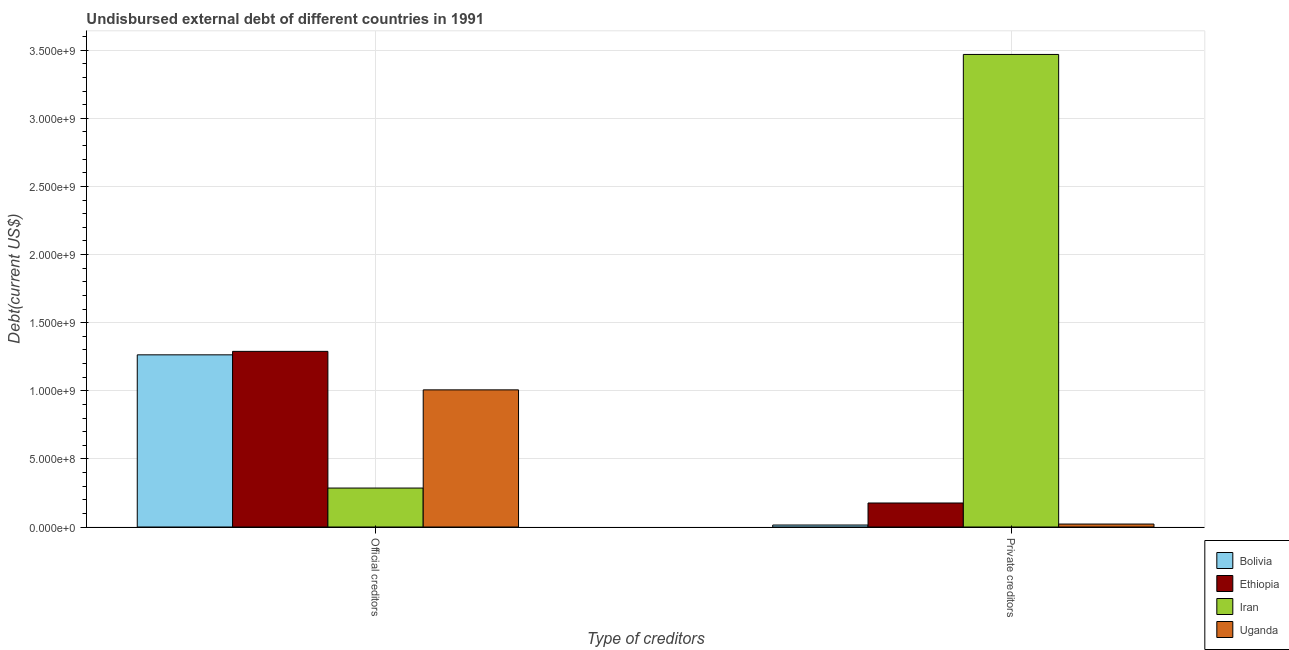Are the number of bars on each tick of the X-axis equal?
Provide a succinct answer. Yes. How many bars are there on the 1st tick from the right?
Ensure brevity in your answer.  4. What is the label of the 1st group of bars from the left?
Keep it short and to the point. Official creditors. What is the undisbursed external debt of official creditors in Ethiopia?
Provide a succinct answer. 1.29e+09. Across all countries, what is the maximum undisbursed external debt of official creditors?
Your answer should be very brief. 1.29e+09. Across all countries, what is the minimum undisbursed external debt of official creditors?
Your response must be concise. 2.86e+08. In which country was the undisbursed external debt of private creditors maximum?
Ensure brevity in your answer.  Iran. In which country was the undisbursed external debt of official creditors minimum?
Offer a terse response. Iran. What is the total undisbursed external debt of official creditors in the graph?
Offer a very short reply. 3.85e+09. What is the difference between the undisbursed external debt of private creditors in Bolivia and that in Ethiopia?
Your response must be concise. -1.62e+08. What is the difference between the undisbursed external debt of official creditors in Uganda and the undisbursed external debt of private creditors in Ethiopia?
Provide a short and direct response. 8.30e+08. What is the average undisbursed external debt of official creditors per country?
Offer a terse response. 9.61e+08. What is the difference between the undisbursed external debt of private creditors and undisbursed external debt of official creditors in Uganda?
Your answer should be compact. -9.85e+08. What is the ratio of the undisbursed external debt of private creditors in Bolivia to that in Iran?
Give a very brief answer. 0. What does the 4th bar from the left in Private creditors represents?
Provide a short and direct response. Uganda. What does the 1st bar from the right in Private creditors represents?
Your answer should be very brief. Uganda. Are the values on the major ticks of Y-axis written in scientific E-notation?
Your response must be concise. Yes. Where does the legend appear in the graph?
Provide a succinct answer. Bottom right. How are the legend labels stacked?
Make the answer very short. Vertical. What is the title of the graph?
Your answer should be very brief. Undisbursed external debt of different countries in 1991. Does "Equatorial Guinea" appear as one of the legend labels in the graph?
Offer a very short reply. No. What is the label or title of the X-axis?
Ensure brevity in your answer.  Type of creditors. What is the label or title of the Y-axis?
Give a very brief answer. Debt(current US$). What is the Debt(current US$) in Bolivia in Official creditors?
Offer a terse response. 1.26e+09. What is the Debt(current US$) in Ethiopia in Official creditors?
Provide a short and direct response. 1.29e+09. What is the Debt(current US$) in Iran in Official creditors?
Offer a very short reply. 2.86e+08. What is the Debt(current US$) in Uganda in Official creditors?
Ensure brevity in your answer.  1.01e+09. What is the Debt(current US$) in Bolivia in Private creditors?
Give a very brief answer. 1.46e+07. What is the Debt(current US$) of Ethiopia in Private creditors?
Provide a succinct answer. 1.76e+08. What is the Debt(current US$) in Iran in Private creditors?
Your answer should be very brief. 3.47e+09. What is the Debt(current US$) in Uganda in Private creditors?
Offer a very short reply. 2.17e+07. Across all Type of creditors, what is the maximum Debt(current US$) in Bolivia?
Your answer should be compact. 1.26e+09. Across all Type of creditors, what is the maximum Debt(current US$) of Ethiopia?
Make the answer very short. 1.29e+09. Across all Type of creditors, what is the maximum Debt(current US$) in Iran?
Ensure brevity in your answer.  3.47e+09. Across all Type of creditors, what is the maximum Debt(current US$) of Uganda?
Provide a succinct answer. 1.01e+09. Across all Type of creditors, what is the minimum Debt(current US$) in Bolivia?
Offer a terse response. 1.46e+07. Across all Type of creditors, what is the minimum Debt(current US$) in Ethiopia?
Offer a terse response. 1.76e+08. Across all Type of creditors, what is the minimum Debt(current US$) in Iran?
Ensure brevity in your answer.  2.86e+08. Across all Type of creditors, what is the minimum Debt(current US$) in Uganda?
Make the answer very short. 2.17e+07. What is the total Debt(current US$) of Bolivia in the graph?
Make the answer very short. 1.28e+09. What is the total Debt(current US$) of Ethiopia in the graph?
Keep it short and to the point. 1.47e+09. What is the total Debt(current US$) in Iran in the graph?
Offer a terse response. 3.75e+09. What is the total Debt(current US$) of Uganda in the graph?
Offer a very short reply. 1.03e+09. What is the difference between the Debt(current US$) in Bolivia in Official creditors and that in Private creditors?
Your answer should be very brief. 1.25e+09. What is the difference between the Debt(current US$) of Ethiopia in Official creditors and that in Private creditors?
Make the answer very short. 1.11e+09. What is the difference between the Debt(current US$) of Iran in Official creditors and that in Private creditors?
Provide a short and direct response. -3.18e+09. What is the difference between the Debt(current US$) in Uganda in Official creditors and that in Private creditors?
Make the answer very short. 9.85e+08. What is the difference between the Debt(current US$) in Bolivia in Official creditors and the Debt(current US$) in Ethiopia in Private creditors?
Offer a very short reply. 1.09e+09. What is the difference between the Debt(current US$) in Bolivia in Official creditors and the Debt(current US$) in Iran in Private creditors?
Your answer should be compact. -2.20e+09. What is the difference between the Debt(current US$) of Bolivia in Official creditors and the Debt(current US$) of Uganda in Private creditors?
Keep it short and to the point. 1.24e+09. What is the difference between the Debt(current US$) in Ethiopia in Official creditors and the Debt(current US$) in Iran in Private creditors?
Provide a short and direct response. -2.18e+09. What is the difference between the Debt(current US$) of Ethiopia in Official creditors and the Debt(current US$) of Uganda in Private creditors?
Give a very brief answer. 1.27e+09. What is the difference between the Debt(current US$) in Iran in Official creditors and the Debt(current US$) in Uganda in Private creditors?
Keep it short and to the point. 2.64e+08. What is the average Debt(current US$) in Bolivia per Type of creditors?
Your answer should be compact. 6.39e+08. What is the average Debt(current US$) in Ethiopia per Type of creditors?
Offer a very short reply. 7.33e+08. What is the average Debt(current US$) in Iran per Type of creditors?
Offer a very short reply. 1.88e+09. What is the average Debt(current US$) in Uganda per Type of creditors?
Your answer should be very brief. 5.14e+08. What is the difference between the Debt(current US$) of Bolivia and Debt(current US$) of Ethiopia in Official creditors?
Your answer should be compact. -2.55e+07. What is the difference between the Debt(current US$) in Bolivia and Debt(current US$) in Iran in Official creditors?
Your answer should be very brief. 9.78e+08. What is the difference between the Debt(current US$) of Bolivia and Debt(current US$) of Uganda in Official creditors?
Provide a succinct answer. 2.57e+08. What is the difference between the Debt(current US$) in Ethiopia and Debt(current US$) in Iran in Official creditors?
Make the answer very short. 1.00e+09. What is the difference between the Debt(current US$) of Ethiopia and Debt(current US$) of Uganda in Official creditors?
Your answer should be very brief. 2.83e+08. What is the difference between the Debt(current US$) of Iran and Debt(current US$) of Uganda in Official creditors?
Offer a very short reply. -7.21e+08. What is the difference between the Debt(current US$) of Bolivia and Debt(current US$) of Ethiopia in Private creditors?
Offer a terse response. -1.62e+08. What is the difference between the Debt(current US$) in Bolivia and Debt(current US$) in Iran in Private creditors?
Give a very brief answer. -3.45e+09. What is the difference between the Debt(current US$) in Bolivia and Debt(current US$) in Uganda in Private creditors?
Keep it short and to the point. -7.11e+06. What is the difference between the Debt(current US$) in Ethiopia and Debt(current US$) in Iran in Private creditors?
Make the answer very short. -3.29e+09. What is the difference between the Debt(current US$) of Ethiopia and Debt(current US$) of Uganda in Private creditors?
Give a very brief answer. 1.55e+08. What is the difference between the Debt(current US$) in Iran and Debt(current US$) in Uganda in Private creditors?
Offer a very short reply. 3.45e+09. What is the ratio of the Debt(current US$) in Bolivia in Official creditors to that in Private creditors?
Make the answer very short. 86.36. What is the ratio of the Debt(current US$) in Ethiopia in Official creditors to that in Private creditors?
Your answer should be compact. 7.31. What is the ratio of the Debt(current US$) of Iran in Official creditors to that in Private creditors?
Make the answer very short. 0.08. What is the ratio of the Debt(current US$) in Uganda in Official creditors to that in Private creditors?
Your answer should be compact. 46.3. What is the difference between the highest and the second highest Debt(current US$) in Bolivia?
Your answer should be compact. 1.25e+09. What is the difference between the highest and the second highest Debt(current US$) in Ethiopia?
Your response must be concise. 1.11e+09. What is the difference between the highest and the second highest Debt(current US$) of Iran?
Ensure brevity in your answer.  3.18e+09. What is the difference between the highest and the second highest Debt(current US$) in Uganda?
Ensure brevity in your answer.  9.85e+08. What is the difference between the highest and the lowest Debt(current US$) of Bolivia?
Your answer should be very brief. 1.25e+09. What is the difference between the highest and the lowest Debt(current US$) in Ethiopia?
Give a very brief answer. 1.11e+09. What is the difference between the highest and the lowest Debt(current US$) of Iran?
Make the answer very short. 3.18e+09. What is the difference between the highest and the lowest Debt(current US$) of Uganda?
Offer a terse response. 9.85e+08. 